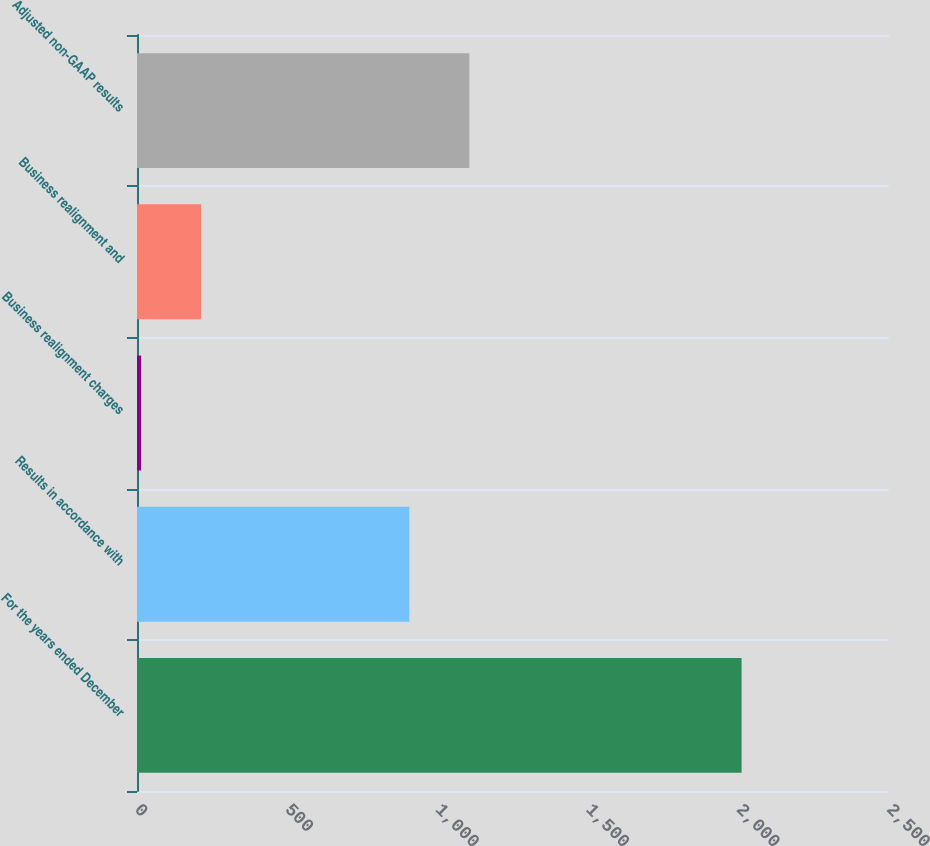Convert chart. <chart><loc_0><loc_0><loc_500><loc_500><bar_chart><fcel>For the years ended December<fcel>Results in accordance with<fcel>Business realignment charges<fcel>Business realignment and<fcel>Adjusted non-GAAP results<nl><fcel>2010<fcel>905.3<fcel>13.7<fcel>213.33<fcel>1104.93<nl></chart> 